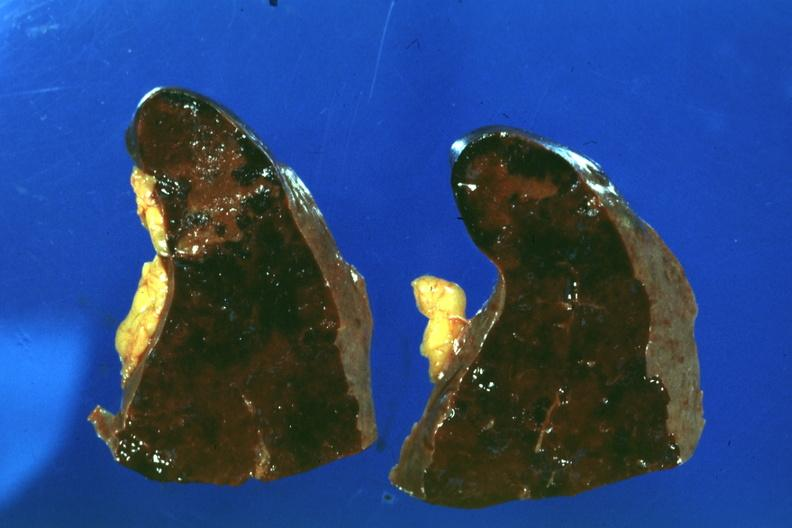s hematologic present?
Answer the question using a single word or phrase. Yes 